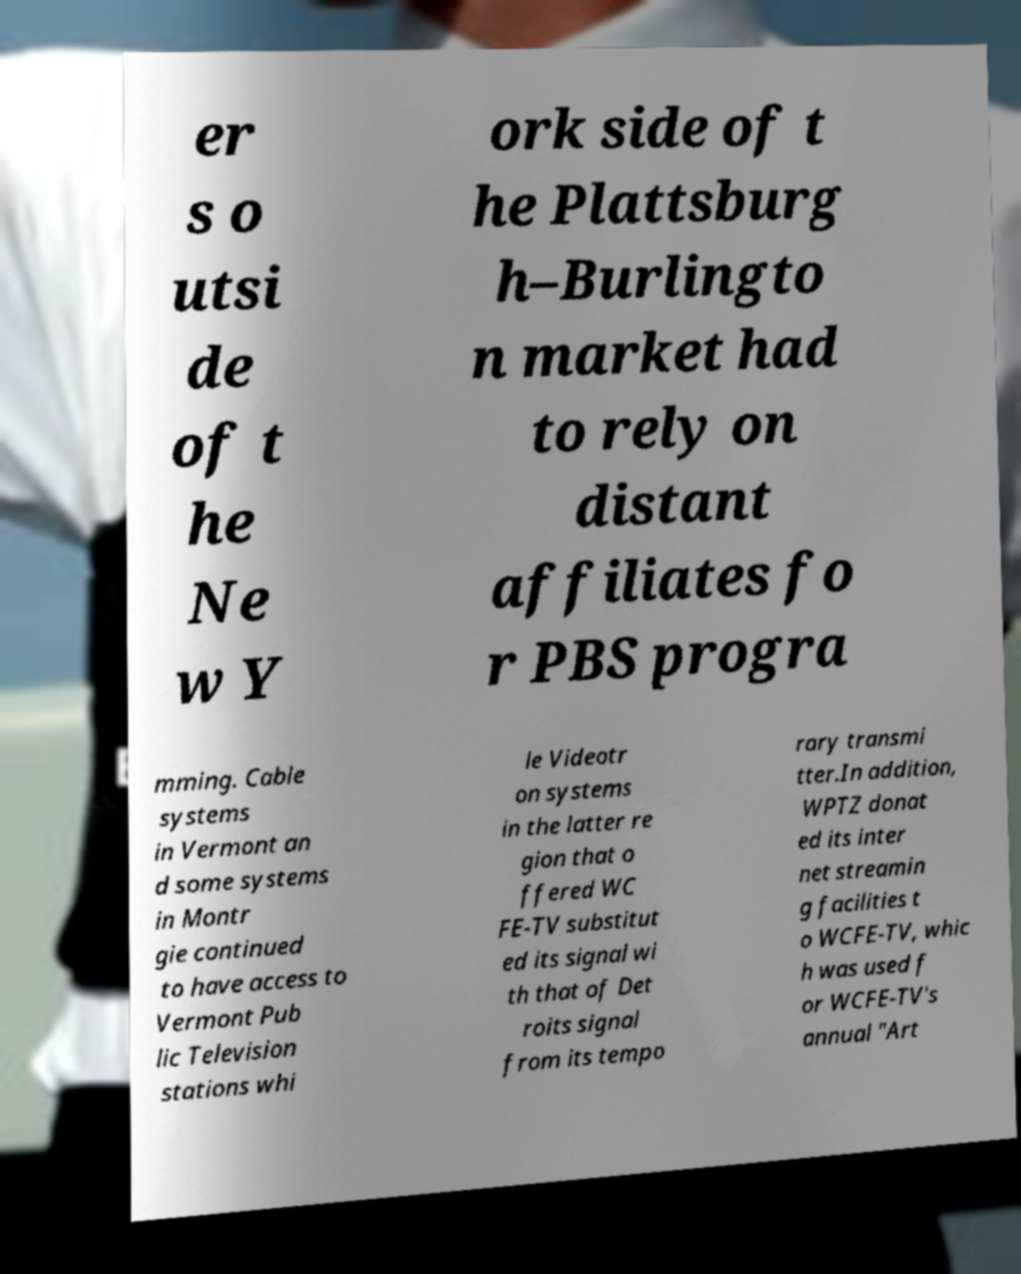Please identify and transcribe the text found in this image. er s o utsi de of t he Ne w Y ork side of t he Plattsburg h–Burlingto n market had to rely on distant affiliates fo r PBS progra mming. Cable systems in Vermont an d some systems in Montr gie continued to have access to Vermont Pub lic Television stations whi le Videotr on systems in the latter re gion that o ffered WC FE-TV substitut ed its signal wi th that of Det roits signal from its tempo rary transmi tter.In addition, WPTZ donat ed its inter net streamin g facilities t o WCFE-TV, whic h was used f or WCFE-TV's annual "Art 